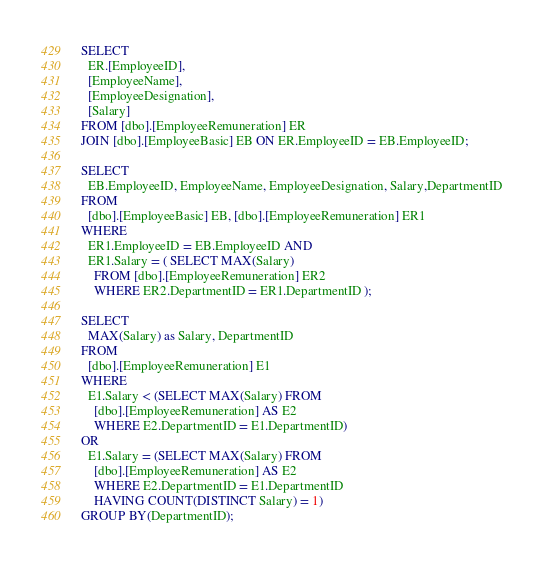Convert code to text. <code><loc_0><loc_0><loc_500><loc_500><_SQL_>SELECT
  ER.[EmployeeID],
  [EmployeeName],
  [EmployeeDesignation],
  [Salary]
FROM [dbo].[EmployeeRemuneration] ER
JOIN [dbo].[EmployeeBasic] EB ON ER.EmployeeID = EB.EmployeeID;

SELECT
  EB.EmployeeID, EmployeeName, EmployeeDesignation, Salary,DepartmentID
FROM
  [dbo].[EmployeeBasic] EB, [dbo].[EmployeeRemuneration] ER1
WHERE
  ER1.EmployeeID = EB.EmployeeID AND
  ER1.Salary = ( SELECT MAX(Salary)
    FROM [dbo].[EmployeeRemuneration] ER2
    WHERE ER2.DepartmentID = ER1.DepartmentID );

SELECT
  MAX(Salary) as Salary, DepartmentID
FROM
  [dbo].[EmployeeRemuneration] E1
WHERE
  E1.Salary < (SELECT MAX(Salary) FROM
    [dbo].[EmployeeRemuneration] AS E2
    WHERE E2.DepartmentID = E1.DepartmentID)
OR
  E1.Salary = (SELECT MAX(Salary) FROM
    [dbo].[EmployeeRemuneration] AS E2
    WHERE E2.DepartmentID = E1.DepartmentID
    HAVING COUNT(DISTINCT Salary) = 1)
GROUP BY(DepartmentID);

</code> 